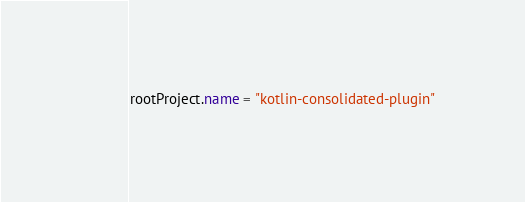<code> <loc_0><loc_0><loc_500><loc_500><_Kotlin_>rootProject.name = "kotlin-consolidated-plugin"
</code> 